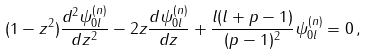<formula> <loc_0><loc_0><loc_500><loc_500>( 1 - z ^ { 2 } ) \frac { d ^ { 2 } \psi ^ { ( n ) } _ { 0 l } } { d z ^ { 2 } } - 2 z \frac { d \psi ^ { ( n ) } _ { 0 l } } { d z } + \frac { l ( l + p - 1 ) } { ( p - 1 ) ^ { 2 } } \psi ^ { ( n ) } _ { 0 l } = 0 \, ,</formula> 